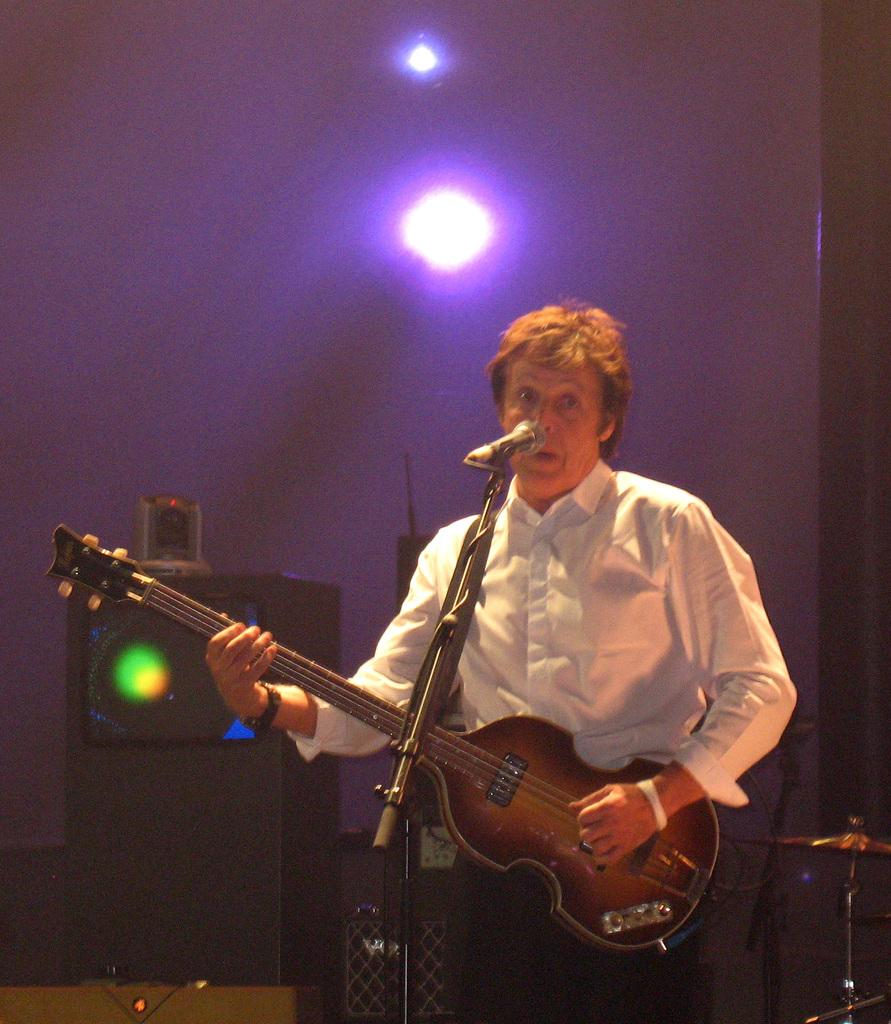What is the man in the image doing? The man is playing a guitar in the image. What object is present that is typically used for amplifying sound? There is a microphone (mike) in the image. What can be seen in the background of the image? There is a wall and a light in the background of the image. Is the man in the image stuck in quicksand while playing the guitar? No, there is no quicksand present in the image. The man is playing the guitar in a normal setting. 